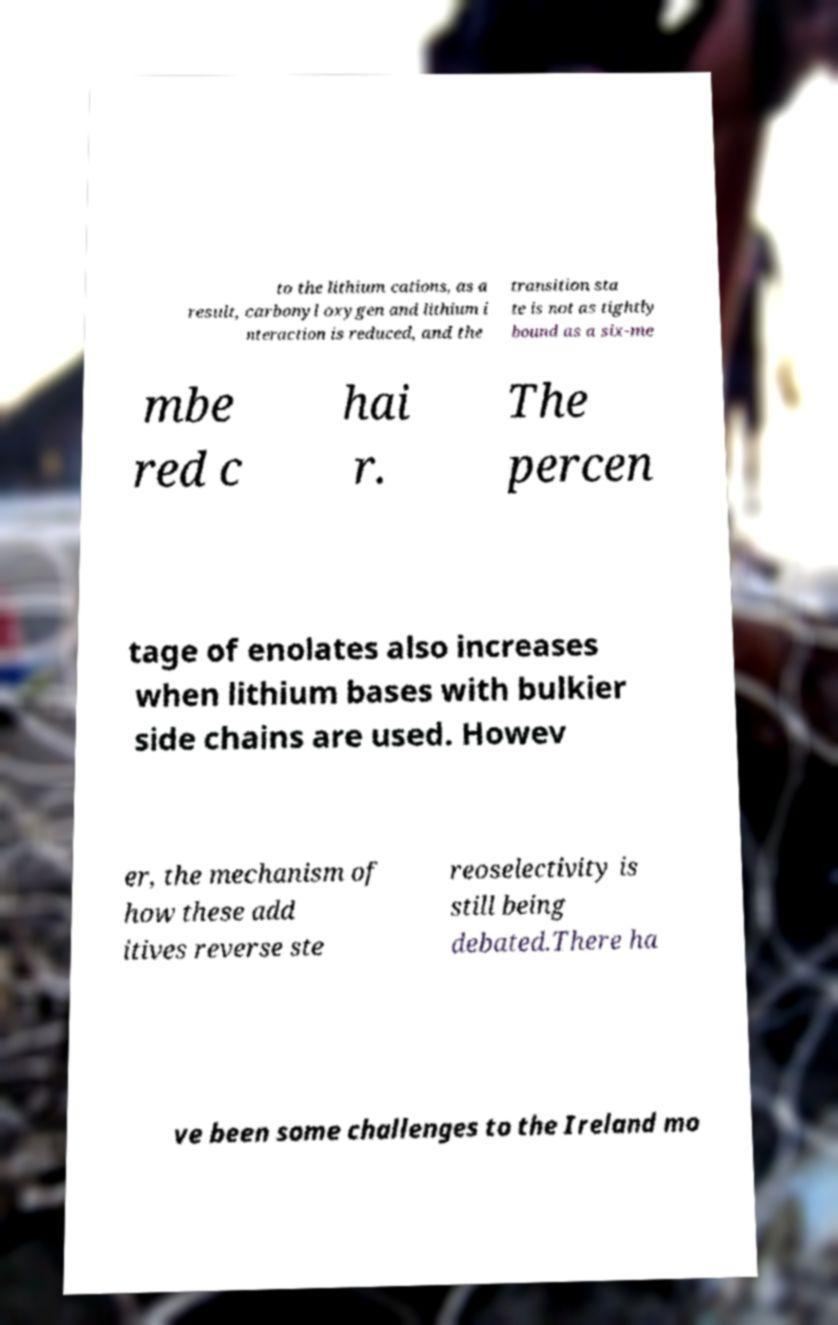There's text embedded in this image that I need extracted. Can you transcribe it verbatim? to the lithium cations, as a result, carbonyl oxygen and lithium i nteraction is reduced, and the transition sta te is not as tightly bound as a six-me mbe red c hai r. The percen tage of enolates also increases when lithium bases with bulkier side chains are used. Howev er, the mechanism of how these add itives reverse ste reoselectivity is still being debated.There ha ve been some challenges to the Ireland mo 